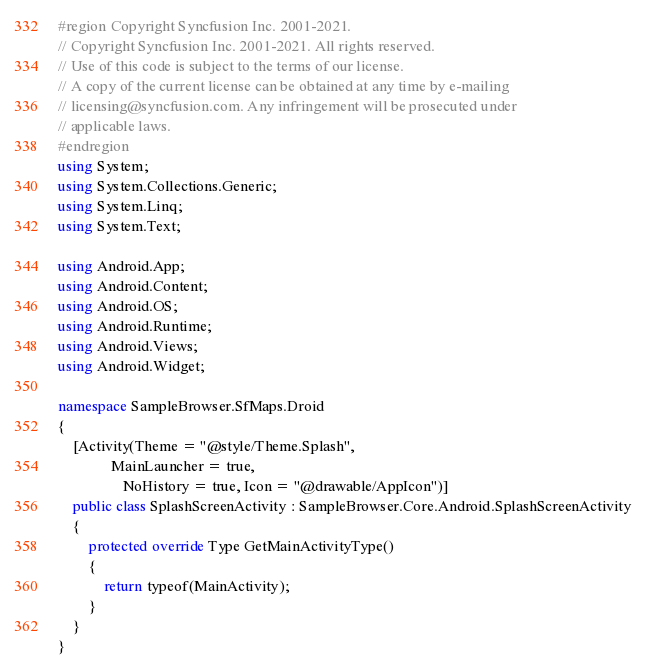<code> <loc_0><loc_0><loc_500><loc_500><_C#_>#region Copyright Syncfusion Inc. 2001-2021.
// Copyright Syncfusion Inc. 2001-2021. All rights reserved.
// Use of this code is subject to the terms of our license.
// A copy of the current license can be obtained at any time by e-mailing
// licensing@syncfusion.com. Any infringement will be prosecuted under
// applicable laws. 
#endregion
using System;
using System.Collections.Generic;
using System.Linq;
using System.Text;

using Android.App;
using Android.Content;
using Android.OS;
using Android.Runtime;
using Android.Views;
using Android.Widget;

namespace SampleBrowser.SfMaps.Droid
{
    [Activity(Theme = "@style/Theme.Splash",
              MainLauncher = true,
                 NoHistory = true, Icon = "@drawable/AppIcon")]
    public class SplashScreenActivity : SampleBrowser.Core.Android.SplashScreenActivity
    {
        protected override Type GetMainActivityType()
        {
            return typeof(MainActivity);
        }
    }
}
</code> 